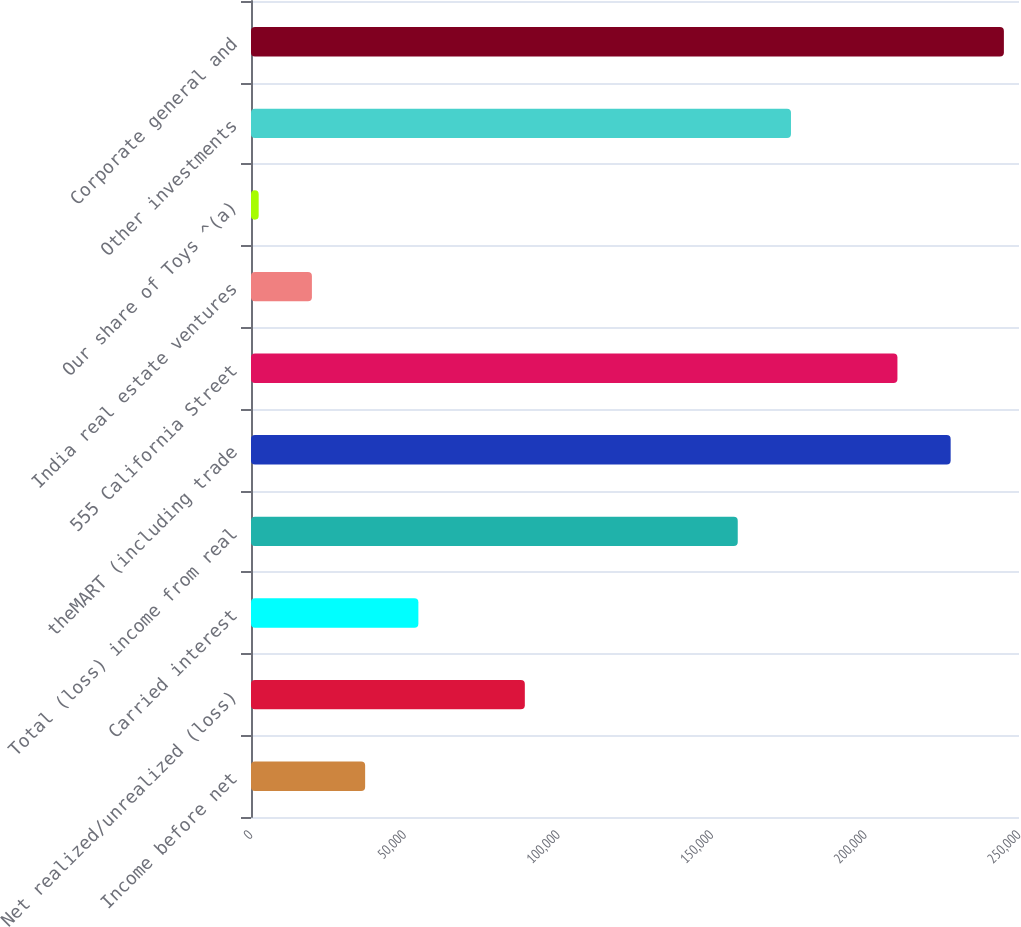<chart> <loc_0><loc_0><loc_500><loc_500><bar_chart><fcel>Income before net<fcel>Net realized/unrealized (loss)<fcel>Carried interest<fcel>Total (loss) income from real<fcel>theMART (including trade<fcel>555 California Street<fcel>India real estate ventures<fcel>Our share of Toys ^(a)<fcel>Other investments<fcel>Corporate general and<nl><fcel>37154.4<fcel>89136<fcel>54481.6<fcel>158445<fcel>227754<fcel>210426<fcel>19827.2<fcel>2500<fcel>175772<fcel>245081<nl></chart> 